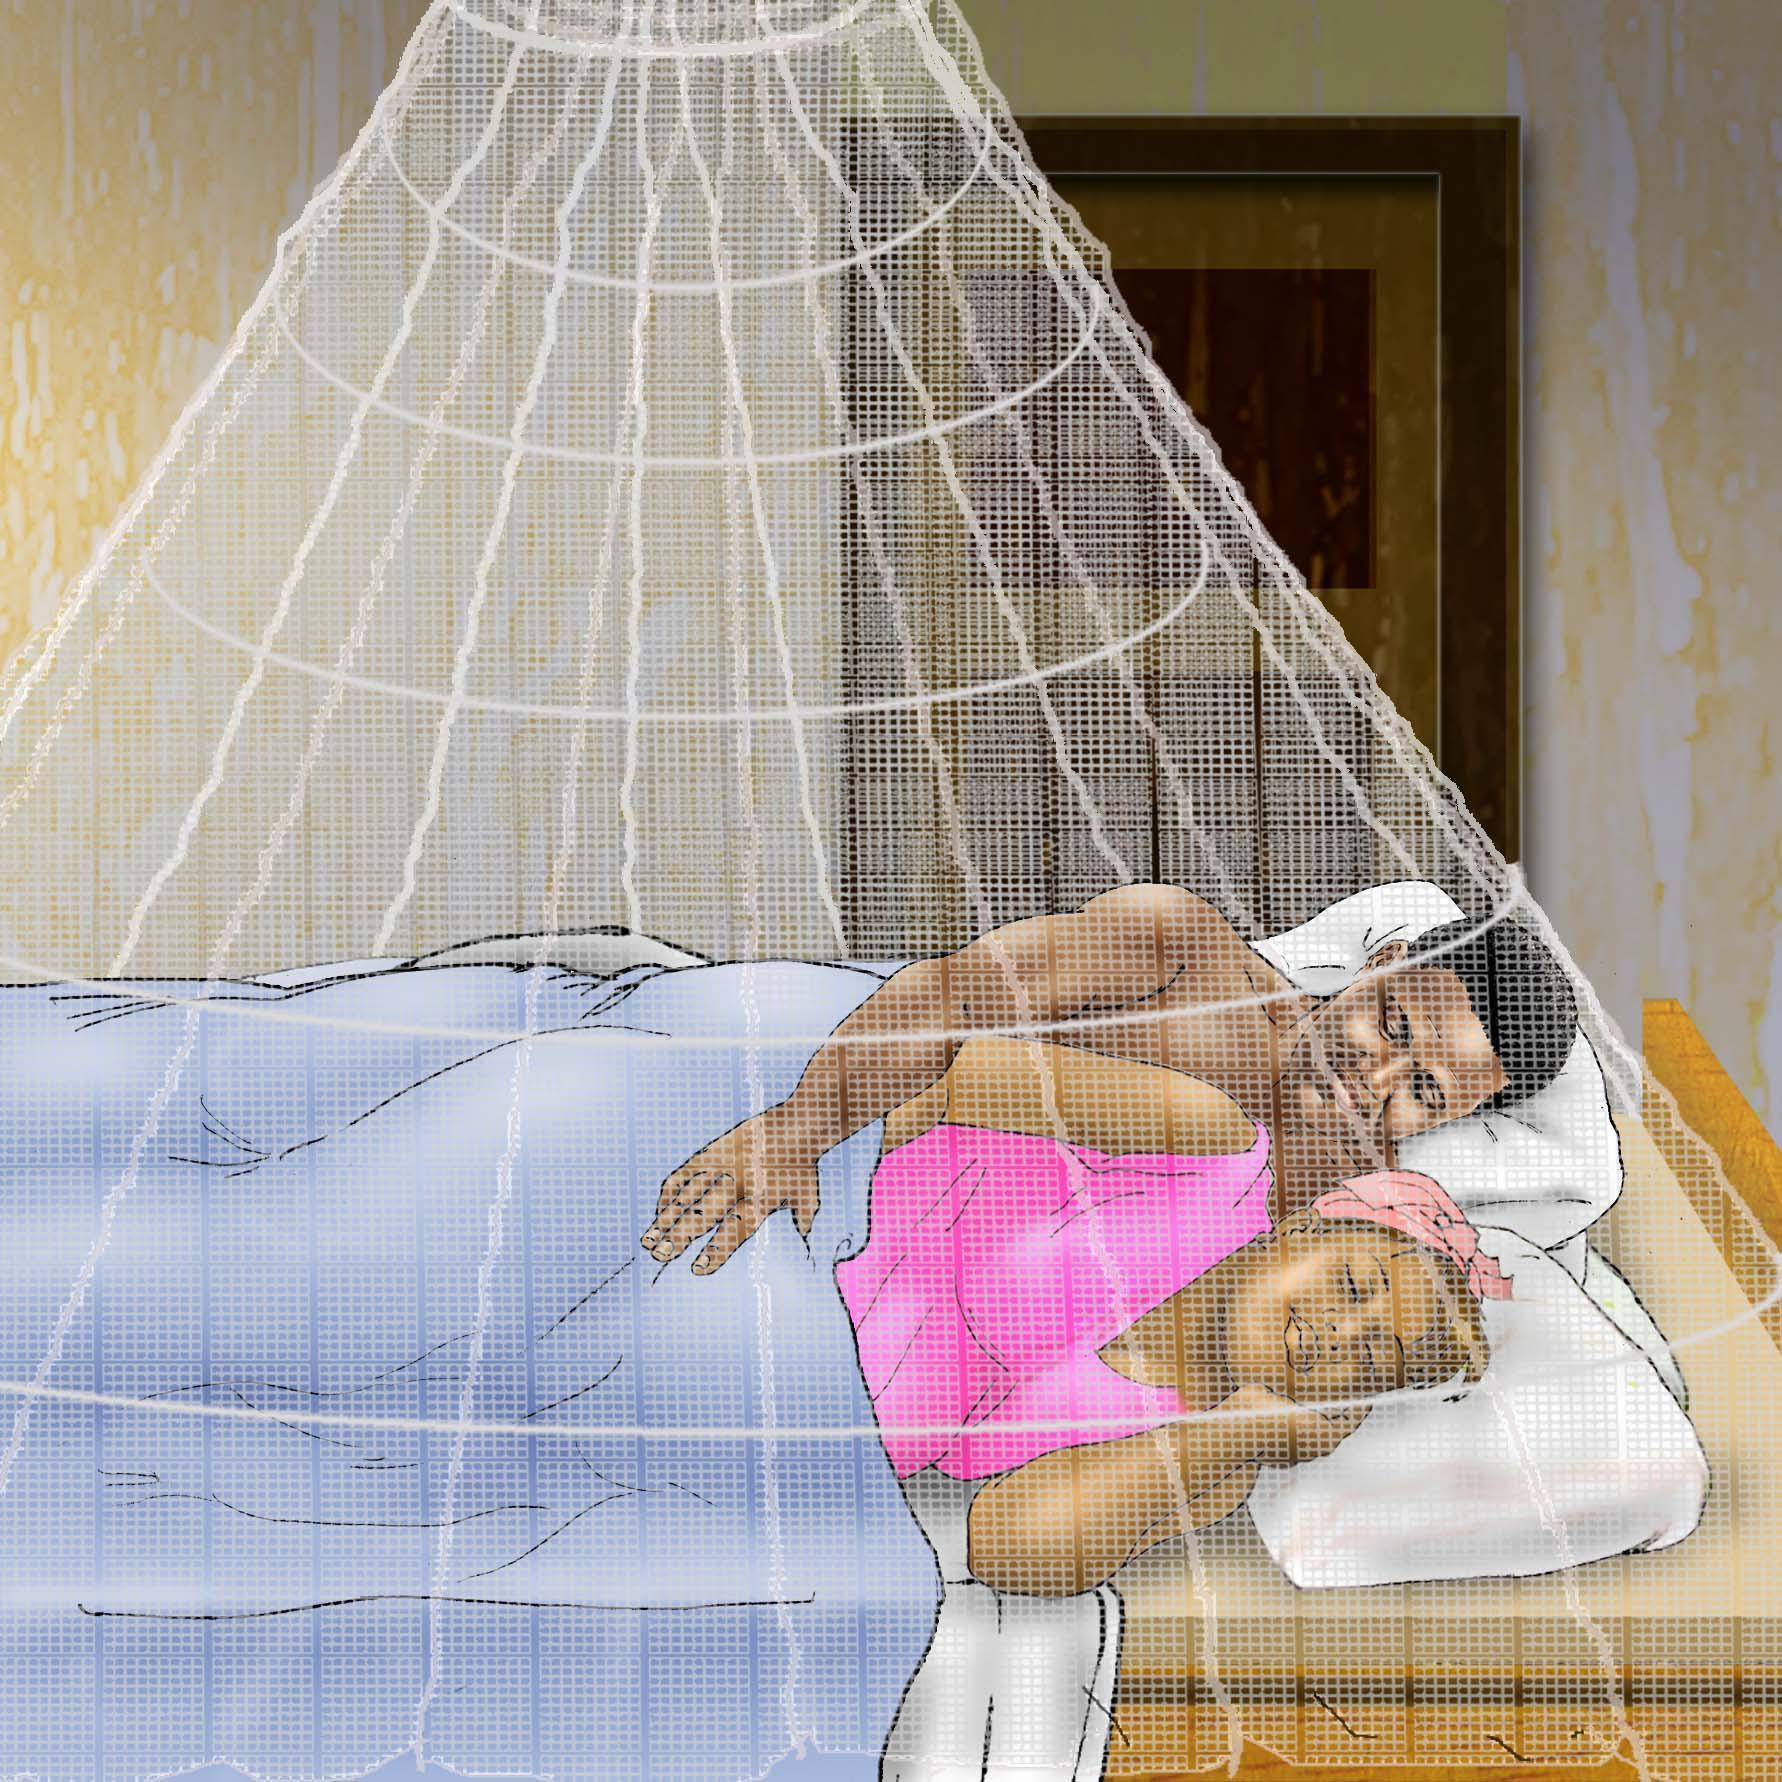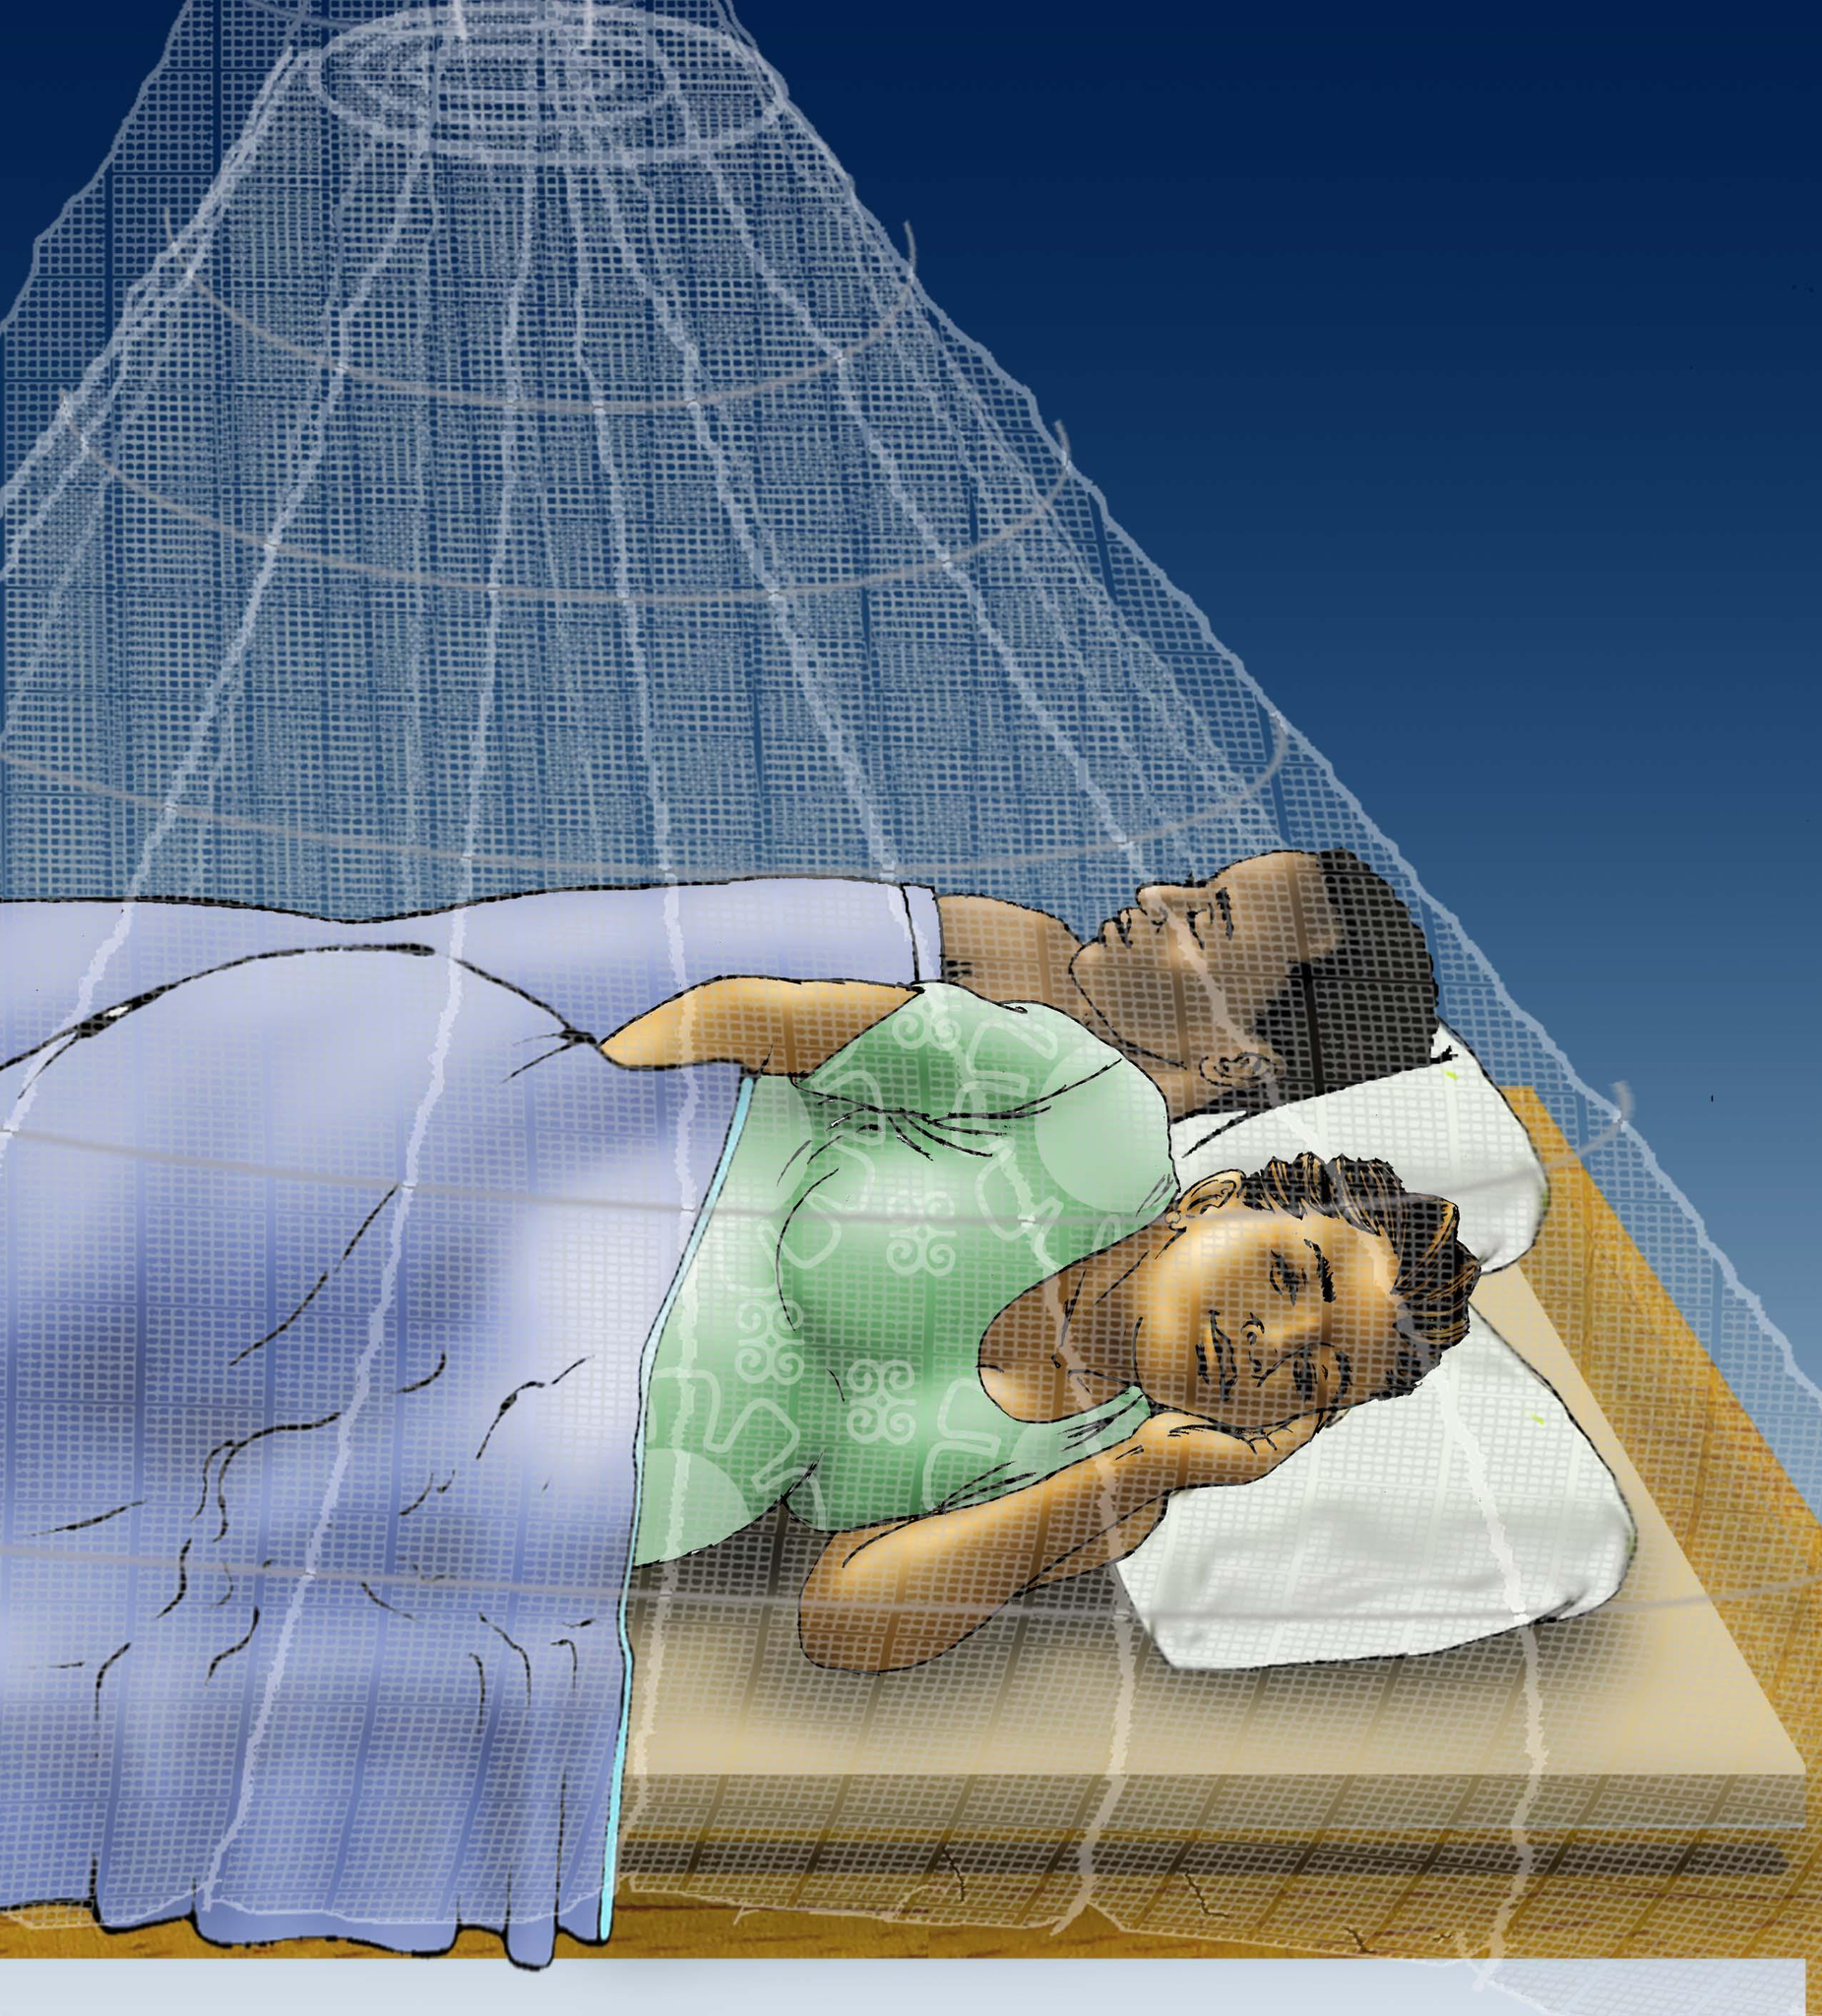The first image is the image on the left, the second image is the image on the right. For the images shown, is this caption "Each image shows a gauzy white canopy that suspends from above to surround a mattress, and at least one image shows two people lying under the canopy." true? Answer yes or no. Yes. The first image is the image on the left, the second image is the image on the right. Assess this claim about the two images: "The left and right image contains the same number of circle canopies.". Correct or not? Answer yes or no. Yes. 